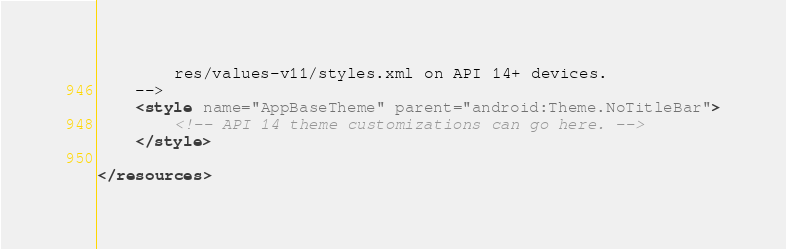Convert code to text. <code><loc_0><loc_0><loc_500><loc_500><_XML_>        res/values-v11/styles.xml on API 14+ devices.
    -->
    <style name="AppBaseTheme" parent="android:Theme.NoTitleBar">
        <!-- API 14 theme customizations can go here. -->
    </style>

</resources>
</code> 